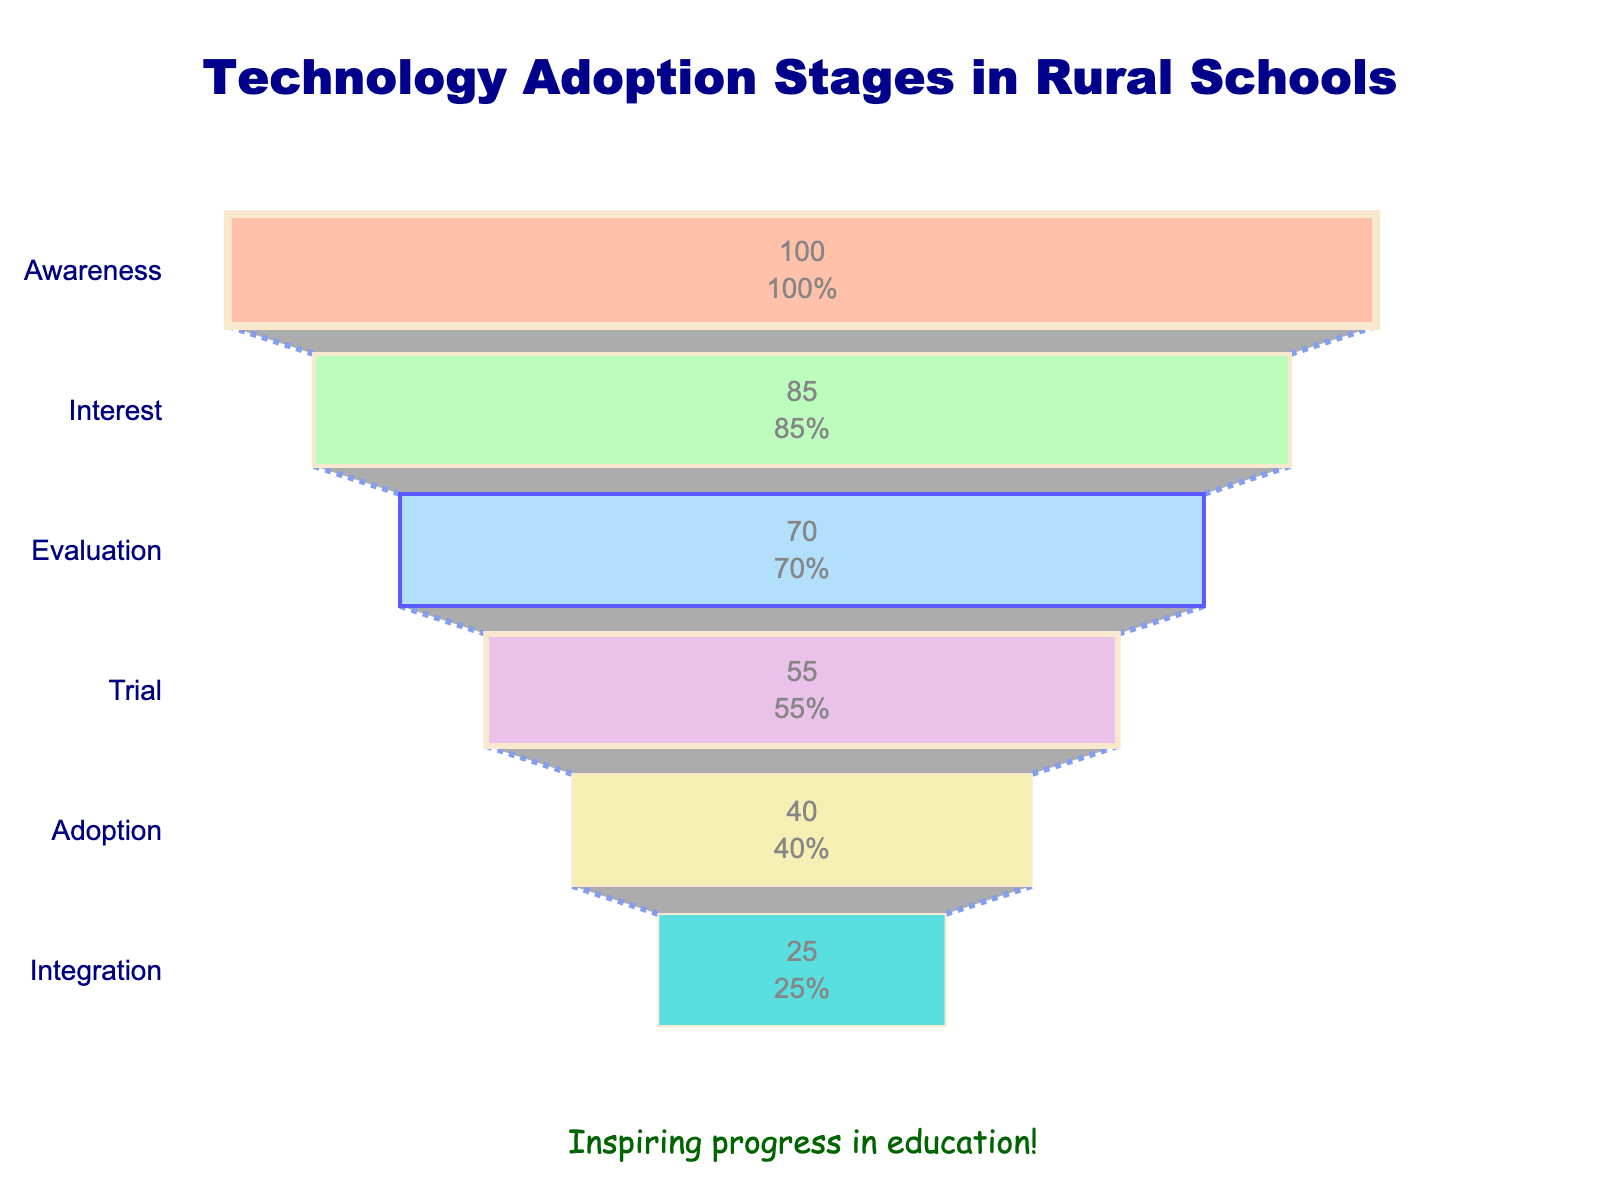What is the title of the funnel chart? The title is usually located at the top of the chart. In this case, it reads "Technology Adoption Stages in Rural Schools".
Answer: Technology Adoption Stages in Rural Schools What stage has the highest percentage of adoption? The highest percentage can be found at the widest part of the funnel. Here, the stage with the highest percentage is Awareness at 100%.
Answer: Awareness Which two stages have the greatest drop in percentage between them? By examining the funnel, we observe the percentages of each stage. The largest decrease is between Evaluation (70%) and Trial (55%), which is a 15% drop.
Answer: Evaluation to Trial How many stages are represented in the funnel chart? By counting each unique labeled segment (Awareness, Interest, Evaluation, Trial, Adoption, Integration), we find there are 6 stages.
Answer: 6 What percentage of schools have integrated the technology? The Integration stage is the final stage at the bottom of the funnel. The percentage here is 25%.
Answer: 25% How much percentage difference is there between the Awareness stage and the Integration stage? The percentage at Awareness is 100% and at Integration is 25%. The difference between these values is 100% - 25% = 75%.
Answer: 75% Which stage follows the Interest stage, and what percentage does it represent? Following the sequence from top to bottom, the stage after Interest (85%) is Evaluation, which is represented by 70%.
Answer: Evaluation, 70% What is the sum of percentages from the Adoption and the Trial stages? The percentages for Adoption and Trial are 40% and 55%, respectively. Adding these gives 40% + 55% = 95%.
Answer: 95% Between Interest and Adoption, which stage has a lower percentage? Comparing the Interest stage (85%) with Adoption stage (40%), Adoption has a lower percentage.
Answer: Adoption What is the decrease in percentage between each consecutive stage from Awareness to Integration? 1. Awareness to Interest: 100% - 85% = 15%
2. Interest to Evaluation: 85% - 70% = 15%
3. Evaluation to Trial: 70% - 55% = 15%
4. Trial to Adoption: 55% - 40% = 15%
5. Adoption to Integration: 40% - 25% = 15%
Answer: 15% each 